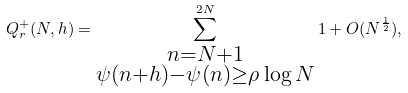<formula> <loc_0><loc_0><loc_500><loc_500>Q _ { r } ^ { + } ( N , h ) = \sum _ { \substack { n = N + 1 \\ \psi ( n + h ) - \psi ( n ) \geq \rho \log N } } ^ { 2 N } 1 + O ( N ^ { \frac { 1 } { 2 } } ) ,</formula> 